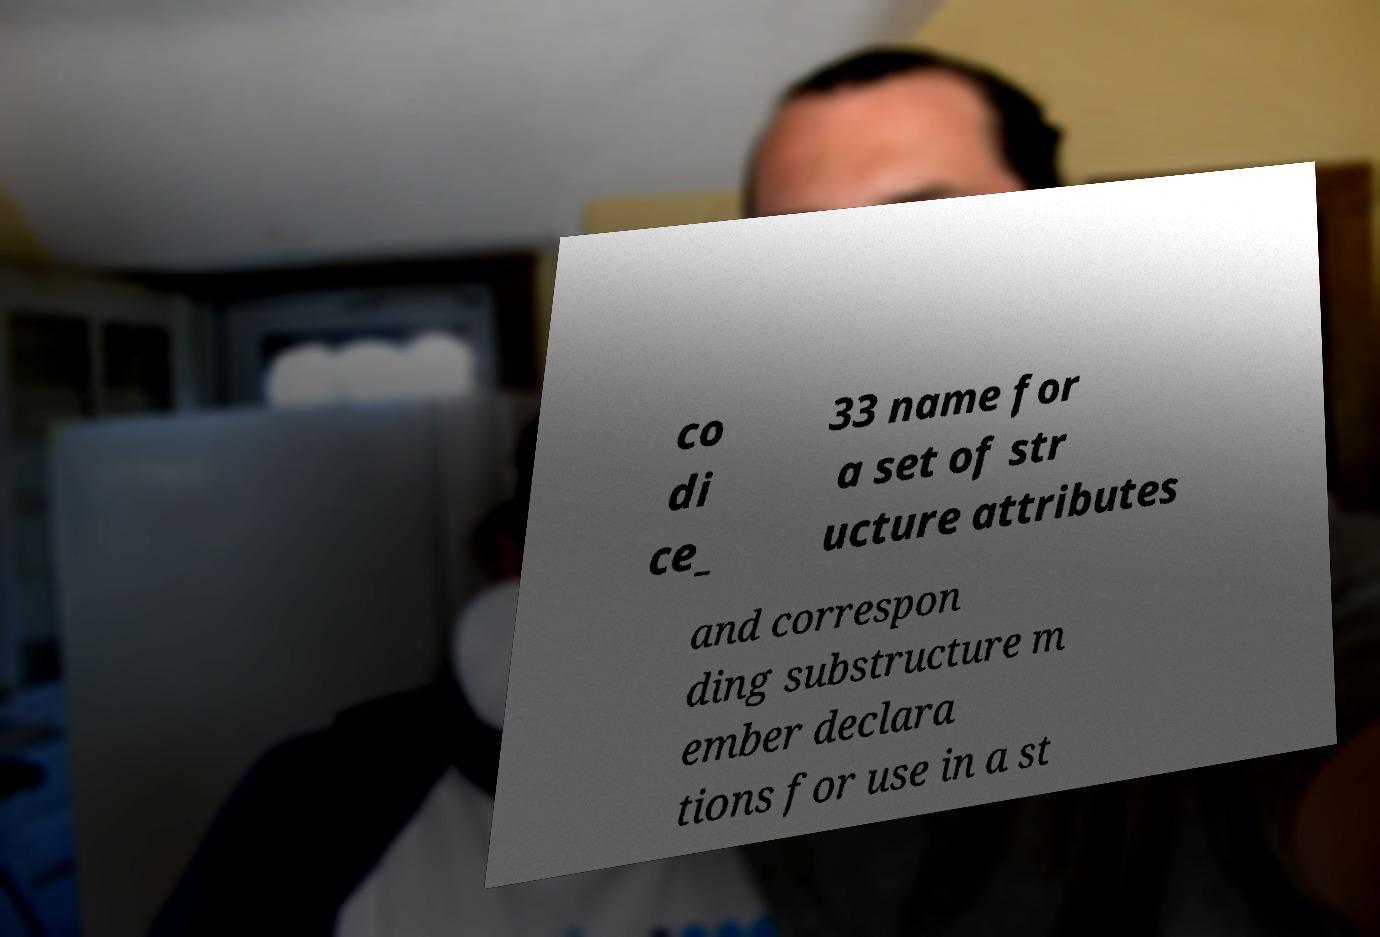For documentation purposes, I need the text within this image transcribed. Could you provide that? co di ce_ 33 name for a set of str ucture attributes and correspon ding substructure m ember declara tions for use in a st 